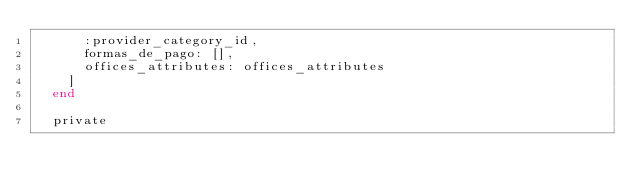<code> <loc_0><loc_0><loc_500><loc_500><_Ruby_>      :provider_category_id,
      formas_de_pago: [],
      offices_attributes: offices_attributes
    ]
  end

  private
</code> 